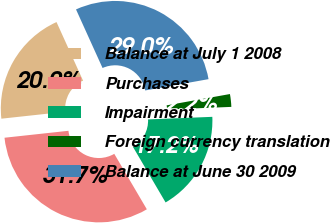Convert chart. <chart><loc_0><loc_0><loc_500><loc_500><pie_chart><fcel>Balance at July 1 2008<fcel>Purchases<fcel>Impairment<fcel>Foreign currency translation<fcel>Balance at June 30 2009<nl><fcel>19.95%<fcel>31.73%<fcel>17.19%<fcel>2.17%<fcel>28.96%<nl></chart> 